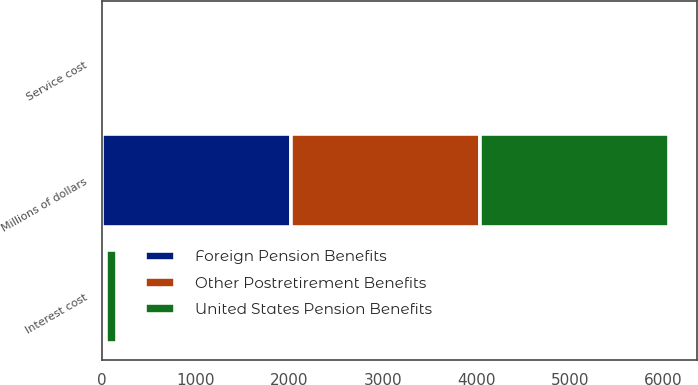Convert chart to OTSL. <chart><loc_0><loc_0><loc_500><loc_500><stacked_bar_chart><ecel><fcel>Millions of dollars<fcel>Service cost<fcel>Interest cost<nl><fcel>United States Pension Benefits<fcel>2018<fcel>2<fcel>118<nl><fcel>Other Postretirement Benefits<fcel>2018<fcel>5<fcel>23<nl><fcel>Foreign Pension Benefits<fcel>2018<fcel>7<fcel>15<nl></chart> 